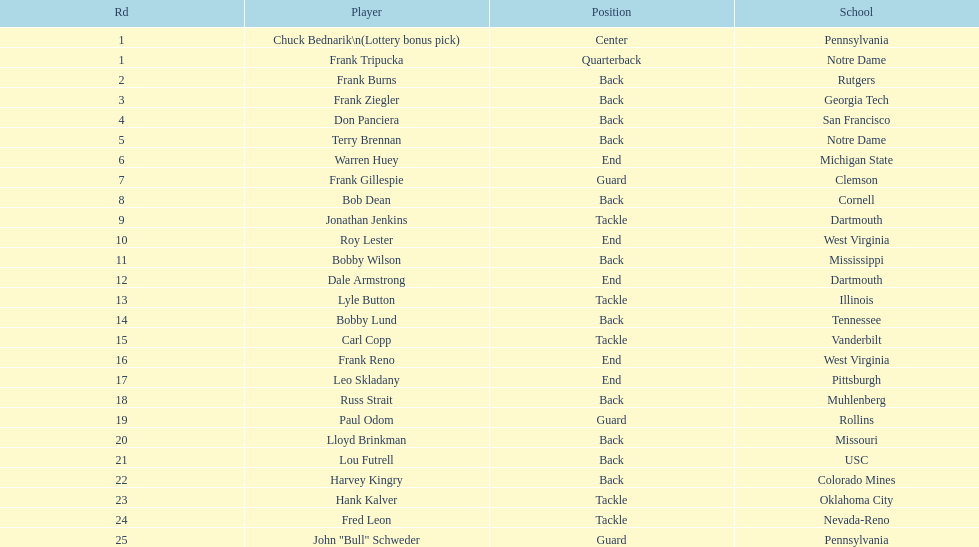Who has same position as frank gillespie? Paul Odom, John "Bull" Schweder. 